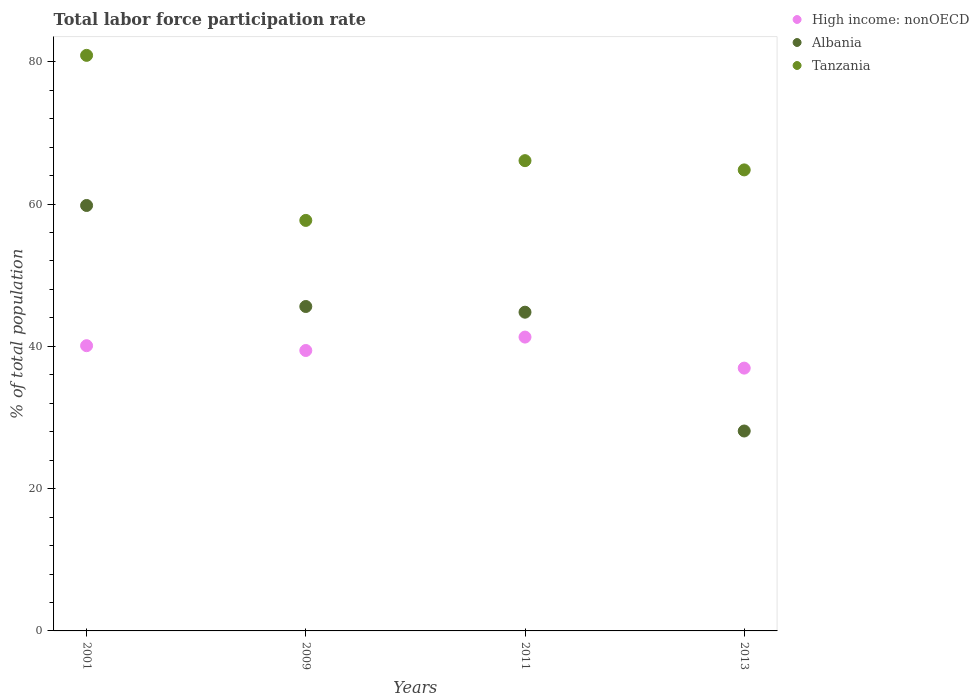How many different coloured dotlines are there?
Provide a short and direct response. 3. What is the total labor force participation rate in Albania in 2009?
Make the answer very short. 45.6. Across all years, what is the maximum total labor force participation rate in Albania?
Offer a terse response. 59.8. Across all years, what is the minimum total labor force participation rate in Tanzania?
Offer a very short reply. 57.7. In which year was the total labor force participation rate in Tanzania minimum?
Give a very brief answer. 2009. What is the total total labor force participation rate in High income: nonOECD in the graph?
Ensure brevity in your answer.  157.75. What is the difference between the total labor force participation rate in High income: nonOECD in 2011 and that in 2013?
Your response must be concise. 4.36. What is the difference between the total labor force participation rate in Albania in 2011 and the total labor force participation rate in Tanzania in 2001?
Offer a terse response. -36.1. What is the average total labor force participation rate in Tanzania per year?
Ensure brevity in your answer.  67.38. In the year 2009, what is the difference between the total labor force participation rate in High income: nonOECD and total labor force participation rate in Albania?
Offer a very short reply. -6.18. In how many years, is the total labor force participation rate in High income: nonOECD greater than 56 %?
Provide a short and direct response. 0. What is the ratio of the total labor force participation rate in Albania in 2009 to that in 2013?
Give a very brief answer. 1.62. Is the difference between the total labor force participation rate in High income: nonOECD in 2001 and 2011 greater than the difference between the total labor force participation rate in Albania in 2001 and 2011?
Give a very brief answer. No. What is the difference between the highest and the second highest total labor force participation rate in Tanzania?
Make the answer very short. 14.8. What is the difference between the highest and the lowest total labor force participation rate in High income: nonOECD?
Offer a terse response. 4.36. In how many years, is the total labor force participation rate in Albania greater than the average total labor force participation rate in Albania taken over all years?
Your answer should be compact. 3. Is it the case that in every year, the sum of the total labor force participation rate in Albania and total labor force participation rate in Tanzania  is greater than the total labor force participation rate in High income: nonOECD?
Your answer should be compact. Yes. Does the total labor force participation rate in Tanzania monotonically increase over the years?
Keep it short and to the point. No. Is the total labor force participation rate in Tanzania strictly greater than the total labor force participation rate in Albania over the years?
Keep it short and to the point. Yes. What is the difference between two consecutive major ticks on the Y-axis?
Keep it short and to the point. 20. Are the values on the major ticks of Y-axis written in scientific E-notation?
Provide a succinct answer. No. Does the graph contain grids?
Give a very brief answer. No. Where does the legend appear in the graph?
Ensure brevity in your answer.  Top right. How many legend labels are there?
Offer a terse response. 3. What is the title of the graph?
Ensure brevity in your answer.  Total labor force participation rate. Does "West Bank and Gaza" appear as one of the legend labels in the graph?
Your answer should be compact. No. What is the label or title of the Y-axis?
Ensure brevity in your answer.  % of total population. What is the % of total population of High income: nonOECD in 2001?
Ensure brevity in your answer.  40.09. What is the % of total population of Albania in 2001?
Provide a short and direct response. 59.8. What is the % of total population in Tanzania in 2001?
Provide a succinct answer. 80.9. What is the % of total population of High income: nonOECD in 2009?
Make the answer very short. 39.42. What is the % of total population in Albania in 2009?
Your answer should be very brief. 45.6. What is the % of total population in Tanzania in 2009?
Your response must be concise. 57.7. What is the % of total population in High income: nonOECD in 2011?
Your response must be concise. 41.3. What is the % of total population in Albania in 2011?
Make the answer very short. 44.8. What is the % of total population in Tanzania in 2011?
Make the answer very short. 66.1. What is the % of total population of High income: nonOECD in 2013?
Ensure brevity in your answer.  36.94. What is the % of total population of Albania in 2013?
Provide a succinct answer. 28.1. What is the % of total population in Tanzania in 2013?
Offer a terse response. 64.8. Across all years, what is the maximum % of total population in High income: nonOECD?
Offer a terse response. 41.3. Across all years, what is the maximum % of total population of Albania?
Your answer should be very brief. 59.8. Across all years, what is the maximum % of total population of Tanzania?
Provide a short and direct response. 80.9. Across all years, what is the minimum % of total population of High income: nonOECD?
Offer a terse response. 36.94. Across all years, what is the minimum % of total population in Albania?
Make the answer very short. 28.1. Across all years, what is the minimum % of total population in Tanzania?
Give a very brief answer. 57.7. What is the total % of total population in High income: nonOECD in the graph?
Your answer should be compact. 157.75. What is the total % of total population of Albania in the graph?
Your response must be concise. 178.3. What is the total % of total population in Tanzania in the graph?
Your answer should be very brief. 269.5. What is the difference between the % of total population of High income: nonOECD in 2001 and that in 2009?
Provide a short and direct response. 0.67. What is the difference between the % of total population in Albania in 2001 and that in 2009?
Offer a terse response. 14.2. What is the difference between the % of total population in Tanzania in 2001 and that in 2009?
Ensure brevity in your answer.  23.2. What is the difference between the % of total population of High income: nonOECD in 2001 and that in 2011?
Provide a succinct answer. -1.21. What is the difference between the % of total population in Albania in 2001 and that in 2011?
Offer a terse response. 15. What is the difference between the % of total population in Tanzania in 2001 and that in 2011?
Make the answer very short. 14.8. What is the difference between the % of total population in High income: nonOECD in 2001 and that in 2013?
Keep it short and to the point. 3.15. What is the difference between the % of total population of Albania in 2001 and that in 2013?
Your answer should be very brief. 31.7. What is the difference between the % of total population in High income: nonOECD in 2009 and that in 2011?
Offer a very short reply. -1.89. What is the difference between the % of total population of Albania in 2009 and that in 2011?
Provide a short and direct response. 0.8. What is the difference between the % of total population in High income: nonOECD in 2009 and that in 2013?
Offer a very short reply. 2.48. What is the difference between the % of total population in Albania in 2009 and that in 2013?
Give a very brief answer. 17.5. What is the difference between the % of total population in Tanzania in 2009 and that in 2013?
Offer a very short reply. -7.1. What is the difference between the % of total population in High income: nonOECD in 2011 and that in 2013?
Your answer should be compact. 4.36. What is the difference between the % of total population in Albania in 2011 and that in 2013?
Your response must be concise. 16.7. What is the difference between the % of total population of Tanzania in 2011 and that in 2013?
Ensure brevity in your answer.  1.3. What is the difference between the % of total population in High income: nonOECD in 2001 and the % of total population in Albania in 2009?
Make the answer very short. -5.51. What is the difference between the % of total population in High income: nonOECD in 2001 and the % of total population in Tanzania in 2009?
Ensure brevity in your answer.  -17.61. What is the difference between the % of total population in Albania in 2001 and the % of total population in Tanzania in 2009?
Your answer should be very brief. 2.1. What is the difference between the % of total population in High income: nonOECD in 2001 and the % of total population in Albania in 2011?
Your response must be concise. -4.71. What is the difference between the % of total population in High income: nonOECD in 2001 and the % of total population in Tanzania in 2011?
Your response must be concise. -26.01. What is the difference between the % of total population of Albania in 2001 and the % of total population of Tanzania in 2011?
Provide a succinct answer. -6.3. What is the difference between the % of total population in High income: nonOECD in 2001 and the % of total population in Albania in 2013?
Make the answer very short. 11.99. What is the difference between the % of total population in High income: nonOECD in 2001 and the % of total population in Tanzania in 2013?
Your response must be concise. -24.71. What is the difference between the % of total population of High income: nonOECD in 2009 and the % of total population of Albania in 2011?
Your response must be concise. -5.38. What is the difference between the % of total population in High income: nonOECD in 2009 and the % of total population in Tanzania in 2011?
Keep it short and to the point. -26.68. What is the difference between the % of total population of Albania in 2009 and the % of total population of Tanzania in 2011?
Offer a terse response. -20.5. What is the difference between the % of total population of High income: nonOECD in 2009 and the % of total population of Albania in 2013?
Your answer should be very brief. 11.32. What is the difference between the % of total population in High income: nonOECD in 2009 and the % of total population in Tanzania in 2013?
Offer a terse response. -25.38. What is the difference between the % of total population of Albania in 2009 and the % of total population of Tanzania in 2013?
Provide a succinct answer. -19.2. What is the difference between the % of total population of High income: nonOECD in 2011 and the % of total population of Albania in 2013?
Your answer should be very brief. 13.2. What is the difference between the % of total population of High income: nonOECD in 2011 and the % of total population of Tanzania in 2013?
Your response must be concise. -23.5. What is the difference between the % of total population of Albania in 2011 and the % of total population of Tanzania in 2013?
Your response must be concise. -20. What is the average % of total population in High income: nonOECD per year?
Your answer should be compact. 39.44. What is the average % of total population of Albania per year?
Your answer should be compact. 44.58. What is the average % of total population in Tanzania per year?
Provide a short and direct response. 67.38. In the year 2001, what is the difference between the % of total population of High income: nonOECD and % of total population of Albania?
Make the answer very short. -19.71. In the year 2001, what is the difference between the % of total population in High income: nonOECD and % of total population in Tanzania?
Your answer should be compact. -40.81. In the year 2001, what is the difference between the % of total population of Albania and % of total population of Tanzania?
Your answer should be compact. -21.1. In the year 2009, what is the difference between the % of total population in High income: nonOECD and % of total population in Albania?
Keep it short and to the point. -6.18. In the year 2009, what is the difference between the % of total population in High income: nonOECD and % of total population in Tanzania?
Make the answer very short. -18.28. In the year 2011, what is the difference between the % of total population in High income: nonOECD and % of total population in Albania?
Offer a terse response. -3.5. In the year 2011, what is the difference between the % of total population in High income: nonOECD and % of total population in Tanzania?
Ensure brevity in your answer.  -24.8. In the year 2011, what is the difference between the % of total population in Albania and % of total population in Tanzania?
Give a very brief answer. -21.3. In the year 2013, what is the difference between the % of total population of High income: nonOECD and % of total population of Albania?
Provide a succinct answer. 8.84. In the year 2013, what is the difference between the % of total population in High income: nonOECD and % of total population in Tanzania?
Make the answer very short. -27.86. In the year 2013, what is the difference between the % of total population of Albania and % of total population of Tanzania?
Keep it short and to the point. -36.7. What is the ratio of the % of total population in High income: nonOECD in 2001 to that in 2009?
Keep it short and to the point. 1.02. What is the ratio of the % of total population of Albania in 2001 to that in 2009?
Your answer should be very brief. 1.31. What is the ratio of the % of total population in Tanzania in 2001 to that in 2009?
Your response must be concise. 1.4. What is the ratio of the % of total population of High income: nonOECD in 2001 to that in 2011?
Provide a short and direct response. 0.97. What is the ratio of the % of total population of Albania in 2001 to that in 2011?
Provide a succinct answer. 1.33. What is the ratio of the % of total population in Tanzania in 2001 to that in 2011?
Your response must be concise. 1.22. What is the ratio of the % of total population in High income: nonOECD in 2001 to that in 2013?
Offer a very short reply. 1.09. What is the ratio of the % of total population of Albania in 2001 to that in 2013?
Give a very brief answer. 2.13. What is the ratio of the % of total population in Tanzania in 2001 to that in 2013?
Offer a very short reply. 1.25. What is the ratio of the % of total population in High income: nonOECD in 2009 to that in 2011?
Keep it short and to the point. 0.95. What is the ratio of the % of total population in Albania in 2009 to that in 2011?
Make the answer very short. 1.02. What is the ratio of the % of total population in Tanzania in 2009 to that in 2011?
Your answer should be compact. 0.87. What is the ratio of the % of total population of High income: nonOECD in 2009 to that in 2013?
Keep it short and to the point. 1.07. What is the ratio of the % of total population of Albania in 2009 to that in 2013?
Offer a very short reply. 1.62. What is the ratio of the % of total population in Tanzania in 2009 to that in 2013?
Provide a succinct answer. 0.89. What is the ratio of the % of total population of High income: nonOECD in 2011 to that in 2013?
Your response must be concise. 1.12. What is the ratio of the % of total population in Albania in 2011 to that in 2013?
Give a very brief answer. 1.59. What is the ratio of the % of total population in Tanzania in 2011 to that in 2013?
Ensure brevity in your answer.  1.02. What is the difference between the highest and the second highest % of total population in High income: nonOECD?
Give a very brief answer. 1.21. What is the difference between the highest and the second highest % of total population of Tanzania?
Make the answer very short. 14.8. What is the difference between the highest and the lowest % of total population of High income: nonOECD?
Your answer should be very brief. 4.36. What is the difference between the highest and the lowest % of total population in Albania?
Offer a terse response. 31.7. What is the difference between the highest and the lowest % of total population in Tanzania?
Your response must be concise. 23.2. 